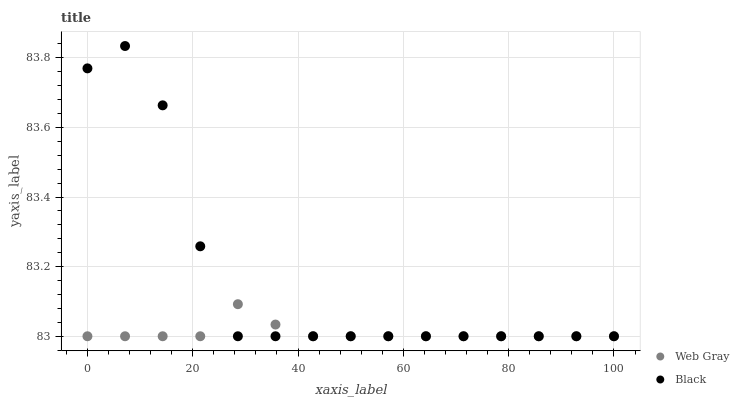Does Web Gray have the minimum area under the curve?
Answer yes or no. Yes. Does Black have the maximum area under the curve?
Answer yes or no. Yes. Does Black have the minimum area under the curve?
Answer yes or no. No. Is Web Gray the smoothest?
Answer yes or no. Yes. Is Black the roughest?
Answer yes or no. Yes. Is Black the smoothest?
Answer yes or no. No. Does Web Gray have the lowest value?
Answer yes or no. Yes. Does Black have the highest value?
Answer yes or no. Yes. Does Web Gray intersect Black?
Answer yes or no. Yes. Is Web Gray less than Black?
Answer yes or no. No. Is Web Gray greater than Black?
Answer yes or no. No. 